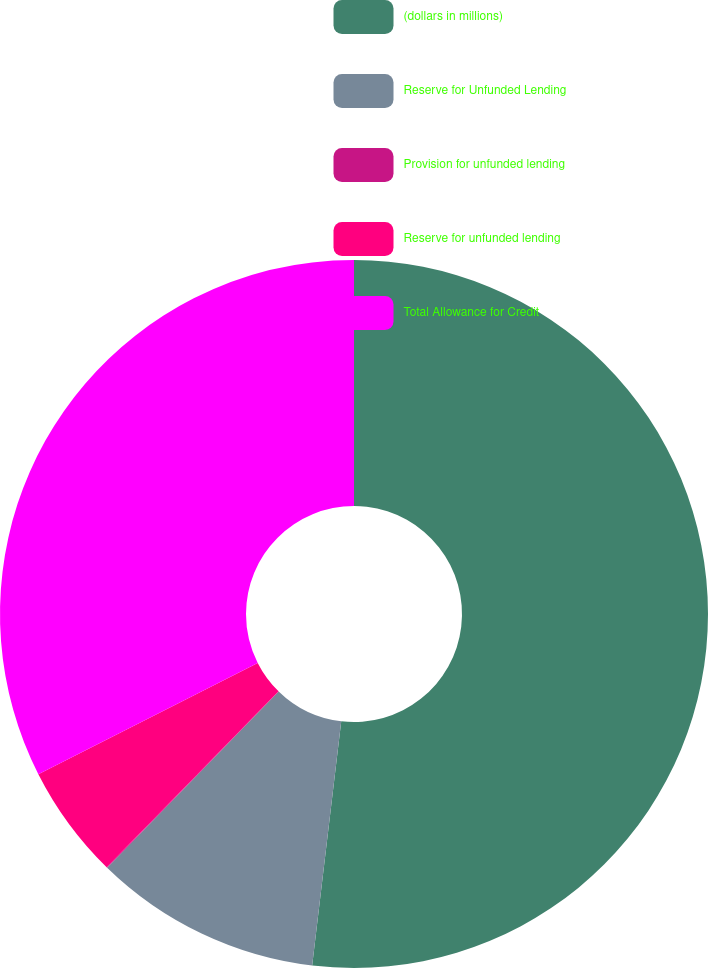<chart> <loc_0><loc_0><loc_500><loc_500><pie_chart><fcel>(dollars in millions)<fcel>Reserve for Unfunded Lending<fcel>Provision for unfunded lending<fcel>Reserve for unfunded lending<fcel>Total Allowance for Credit<nl><fcel>51.89%<fcel>10.4%<fcel>0.03%<fcel>5.21%<fcel>32.48%<nl></chart> 